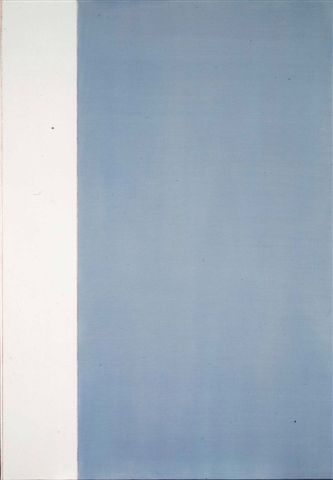Imagine this artwork as part of a larger series. What might the other pieces look like? In a larger series, each piece might explore different aspects of duality and transition using similar minimalistic techniques. One artwork could feature a warm spectrum, with a gradient transitioning from deep red to soft orange, symbolizing passion and energy. Another might use shades of green, ranging from dark forest green at the bottom to light mint at the top, signifying growth and renewal. A series piece might even incorporate textures or subtle patterns within the color fields to suggest different layers of meaning or experience. Together, this series could form a cohesive exploration of contrasts and the movement between different states of being. How could this art piece fit into everyday scenarios? In an everyday scenario, this art piece could serve as a focal point in a contemporary living room or office, providing a calm and sophisticated aesthetic. Its minimalist design and serene color palette would complement modern, clean-lined furniture and decor, creating an atmosphere of tranquility and elegance. Alternatively, the artwork could be used in a meditation or yoga space, where its simplicity and balance promote a sense of peace and introspection, aiding in mindfulness and relaxation practices. 